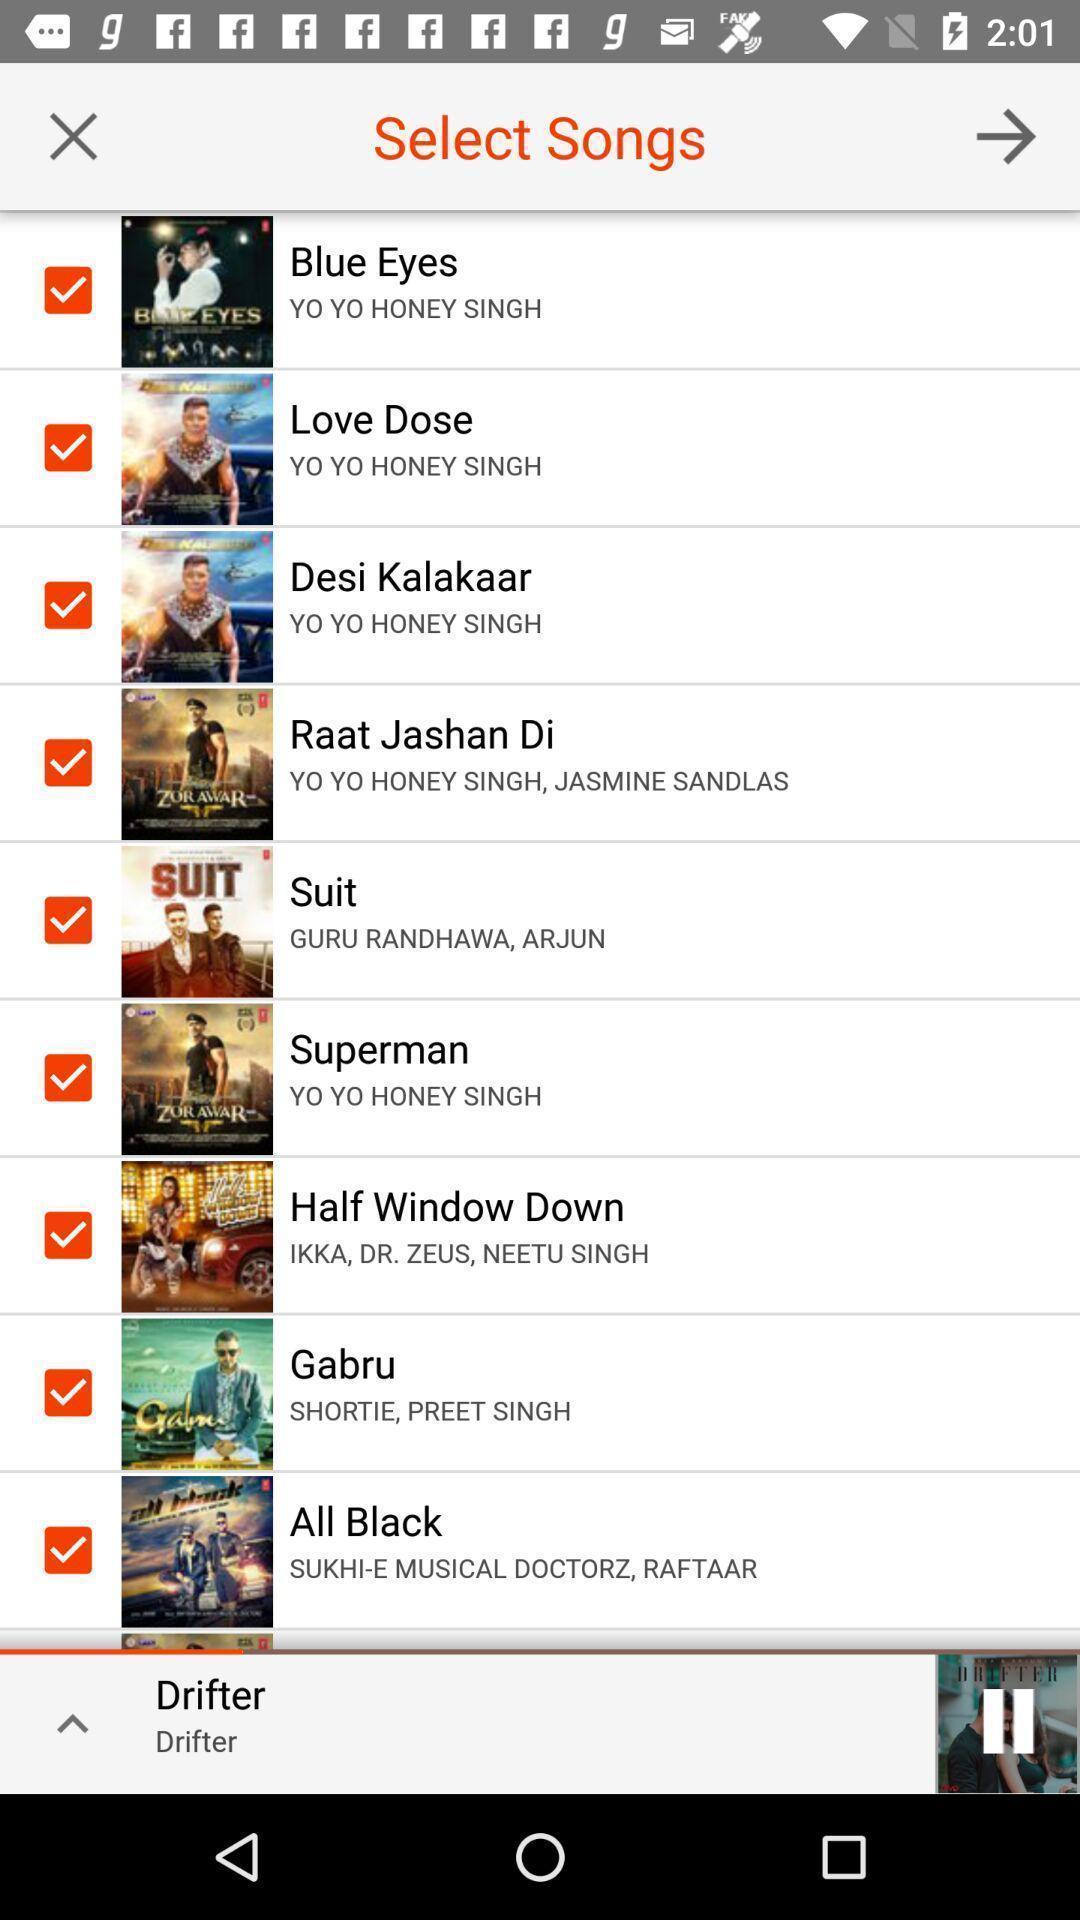What can you discern from this picture? Screen showing the listing of songs. 